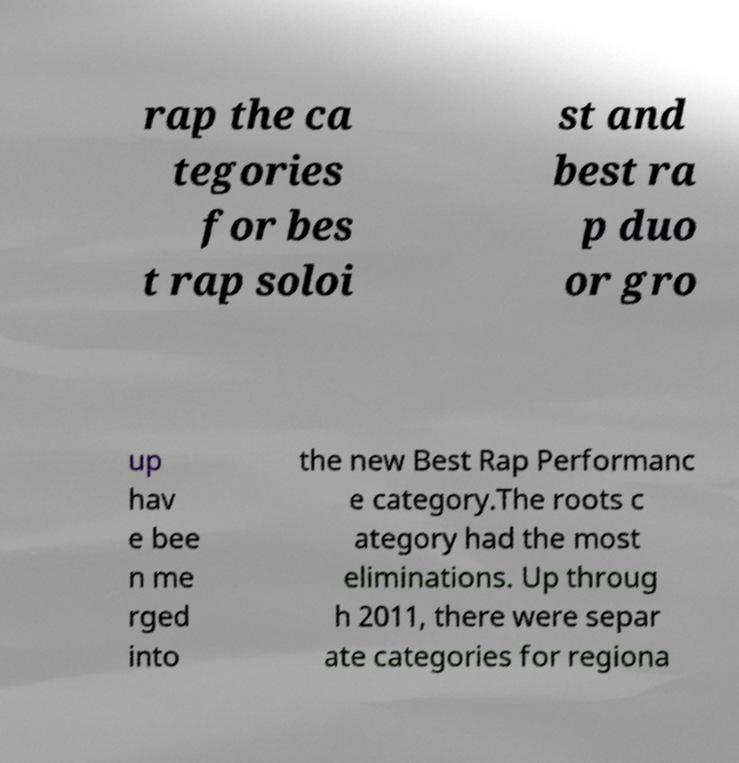Please read and relay the text visible in this image. What does it say? rap the ca tegories for bes t rap soloi st and best ra p duo or gro up hav e bee n me rged into the new Best Rap Performanc e category.The roots c ategory had the most eliminations. Up throug h 2011, there were separ ate categories for regiona 